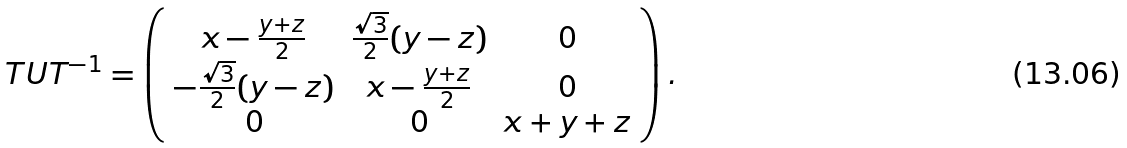<formula> <loc_0><loc_0><loc_500><loc_500>T U T ^ { - 1 } = \left ( \begin{array} { c c c } x - \frac { y + z } { 2 } & \frac { \sqrt { 3 } } { 2 } ( y - z ) & 0 \\ - \frac { \sqrt { 3 } } { 2 } ( y - z ) & x - \frac { y + z } { 2 } & 0 \\ 0 & 0 & x + y + z \end{array} \right ) .</formula> 